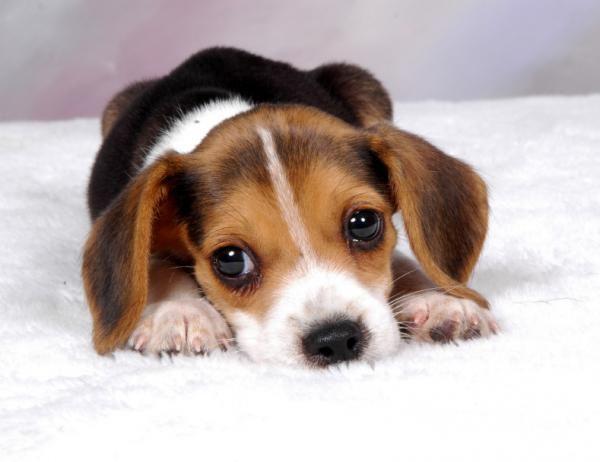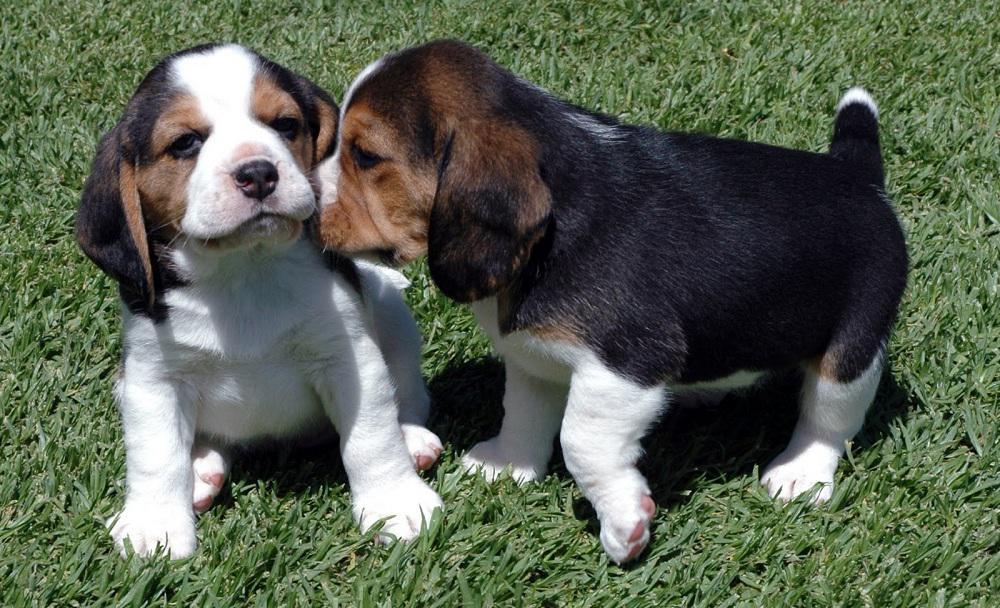The first image is the image on the left, the second image is the image on the right. Examine the images to the left and right. Is the description "In one of the images, there are more than three puppies." accurate? Answer yes or no. No. The first image is the image on the left, the second image is the image on the right. Analyze the images presented: Is the assertion "There are at most three dogs." valid? Answer yes or no. Yes. 